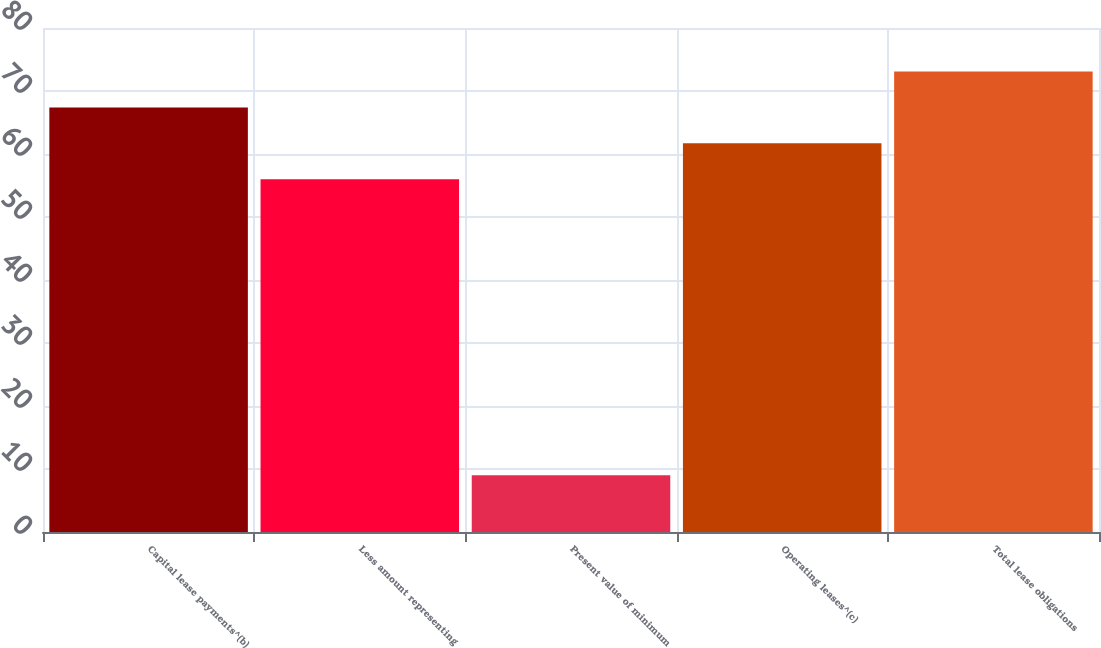Convert chart. <chart><loc_0><loc_0><loc_500><loc_500><bar_chart><fcel>Capital lease payments^(b)<fcel>Less amount representing<fcel>Present value of minimum<fcel>Operating leases^(c)<fcel>Total lease obligations<nl><fcel>67.4<fcel>56<fcel>9<fcel>61.7<fcel>73.1<nl></chart> 